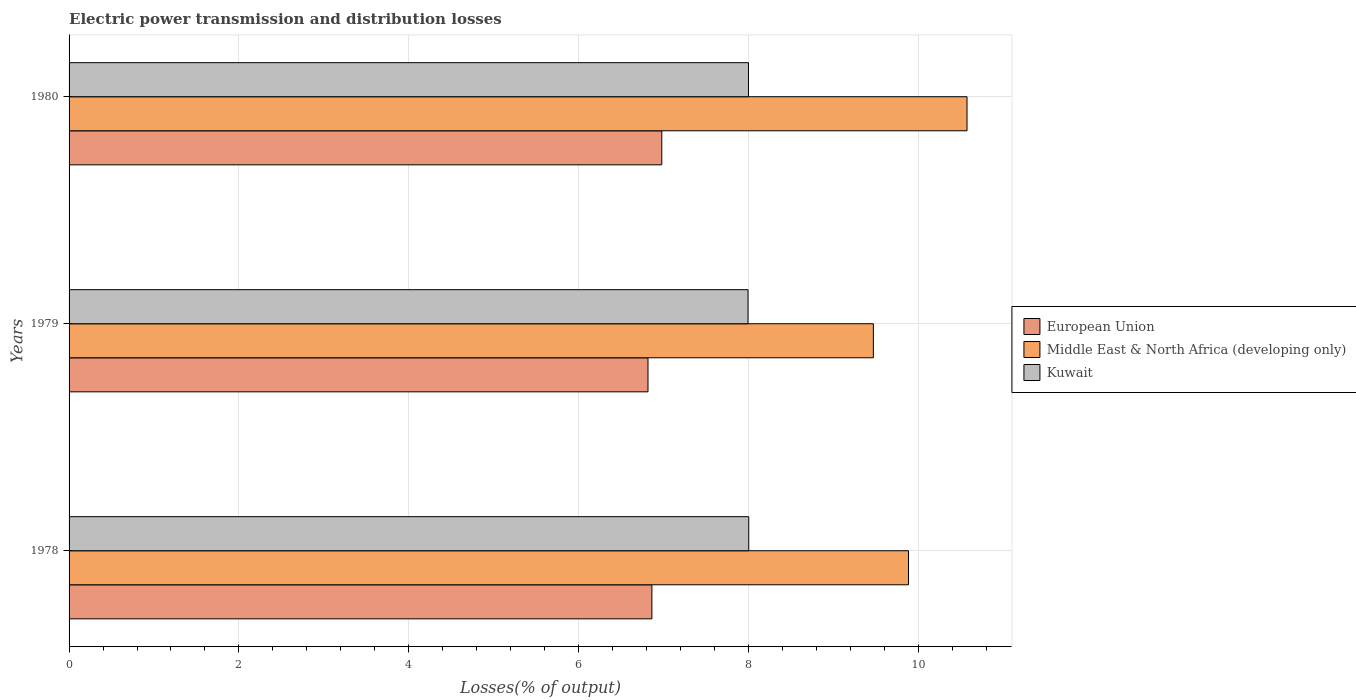How many different coloured bars are there?
Make the answer very short. 3. How many groups of bars are there?
Make the answer very short. 3. How many bars are there on the 2nd tick from the top?
Provide a short and direct response. 3. How many bars are there on the 2nd tick from the bottom?
Keep it short and to the point. 3. What is the label of the 1st group of bars from the top?
Your response must be concise. 1980. What is the electric power transmission and distribution losses in Middle East & North Africa (developing only) in 1980?
Provide a succinct answer. 10.58. Across all years, what is the maximum electric power transmission and distribution losses in Kuwait?
Your answer should be compact. 8.01. Across all years, what is the minimum electric power transmission and distribution losses in Middle East & North Africa (developing only)?
Your response must be concise. 9.47. In which year was the electric power transmission and distribution losses in Kuwait minimum?
Keep it short and to the point. 1979. What is the total electric power transmission and distribution losses in Kuwait in the graph?
Make the answer very short. 24. What is the difference between the electric power transmission and distribution losses in Kuwait in 1978 and that in 1979?
Your answer should be compact. 0.01. What is the difference between the electric power transmission and distribution losses in Middle East & North Africa (developing only) in 1979 and the electric power transmission and distribution losses in Kuwait in 1978?
Offer a terse response. 1.47. What is the average electric power transmission and distribution losses in European Union per year?
Offer a terse response. 6.89. In the year 1978, what is the difference between the electric power transmission and distribution losses in Middle East & North Africa (developing only) and electric power transmission and distribution losses in Kuwait?
Your response must be concise. 1.88. What is the ratio of the electric power transmission and distribution losses in European Union in 1979 to that in 1980?
Offer a terse response. 0.98. Is the electric power transmission and distribution losses in European Union in 1978 less than that in 1980?
Provide a succinct answer. Yes. Is the difference between the electric power transmission and distribution losses in Middle East & North Africa (developing only) in 1979 and 1980 greater than the difference between the electric power transmission and distribution losses in Kuwait in 1979 and 1980?
Provide a succinct answer. No. What is the difference between the highest and the second highest electric power transmission and distribution losses in Middle East & North Africa (developing only)?
Ensure brevity in your answer.  0.69. What is the difference between the highest and the lowest electric power transmission and distribution losses in Middle East & North Africa (developing only)?
Your answer should be very brief. 1.1. What does the 1st bar from the top in 1979 represents?
Your answer should be compact. Kuwait. What does the 2nd bar from the bottom in 1979 represents?
Your response must be concise. Middle East & North Africa (developing only). Is it the case that in every year, the sum of the electric power transmission and distribution losses in Middle East & North Africa (developing only) and electric power transmission and distribution losses in European Union is greater than the electric power transmission and distribution losses in Kuwait?
Provide a short and direct response. Yes. Does the graph contain grids?
Your response must be concise. Yes. Where does the legend appear in the graph?
Ensure brevity in your answer.  Center right. What is the title of the graph?
Ensure brevity in your answer.  Electric power transmission and distribution losses. What is the label or title of the X-axis?
Your response must be concise. Losses(% of output). What is the label or title of the Y-axis?
Provide a short and direct response. Years. What is the Losses(% of output) of European Union in 1978?
Provide a short and direct response. 6.86. What is the Losses(% of output) in Middle East & North Africa (developing only) in 1978?
Your answer should be compact. 9.89. What is the Losses(% of output) of Kuwait in 1978?
Keep it short and to the point. 8.01. What is the Losses(% of output) of European Union in 1979?
Offer a terse response. 6.82. What is the Losses(% of output) of Middle East & North Africa (developing only) in 1979?
Make the answer very short. 9.47. What is the Losses(% of output) of Kuwait in 1979?
Make the answer very short. 8. What is the Losses(% of output) in European Union in 1980?
Your response must be concise. 6.98. What is the Losses(% of output) in Middle East & North Africa (developing only) in 1980?
Give a very brief answer. 10.58. What is the Losses(% of output) in Kuwait in 1980?
Your answer should be very brief. 8. Across all years, what is the maximum Losses(% of output) in European Union?
Keep it short and to the point. 6.98. Across all years, what is the maximum Losses(% of output) of Middle East & North Africa (developing only)?
Your response must be concise. 10.58. Across all years, what is the maximum Losses(% of output) in Kuwait?
Ensure brevity in your answer.  8.01. Across all years, what is the minimum Losses(% of output) of European Union?
Your response must be concise. 6.82. Across all years, what is the minimum Losses(% of output) in Middle East & North Africa (developing only)?
Your answer should be compact. 9.47. Across all years, what is the minimum Losses(% of output) in Kuwait?
Your response must be concise. 8. What is the total Losses(% of output) in European Union in the graph?
Keep it short and to the point. 20.66. What is the total Losses(% of output) in Middle East & North Africa (developing only) in the graph?
Provide a short and direct response. 29.94. What is the total Losses(% of output) in Kuwait in the graph?
Keep it short and to the point. 24. What is the difference between the Losses(% of output) in European Union in 1978 and that in 1979?
Keep it short and to the point. 0.05. What is the difference between the Losses(% of output) of Middle East & North Africa (developing only) in 1978 and that in 1979?
Your answer should be very brief. 0.41. What is the difference between the Losses(% of output) in Kuwait in 1978 and that in 1979?
Offer a very short reply. 0.01. What is the difference between the Losses(% of output) of European Union in 1978 and that in 1980?
Ensure brevity in your answer.  -0.12. What is the difference between the Losses(% of output) in Middle East & North Africa (developing only) in 1978 and that in 1980?
Keep it short and to the point. -0.69. What is the difference between the Losses(% of output) in Kuwait in 1978 and that in 1980?
Offer a very short reply. 0. What is the difference between the Losses(% of output) in European Union in 1979 and that in 1980?
Your answer should be very brief. -0.16. What is the difference between the Losses(% of output) in Middle East & North Africa (developing only) in 1979 and that in 1980?
Provide a succinct answer. -1.1. What is the difference between the Losses(% of output) of Kuwait in 1979 and that in 1980?
Provide a short and direct response. -0.01. What is the difference between the Losses(% of output) in European Union in 1978 and the Losses(% of output) in Middle East & North Africa (developing only) in 1979?
Offer a very short reply. -2.61. What is the difference between the Losses(% of output) of European Union in 1978 and the Losses(% of output) of Kuwait in 1979?
Offer a very short reply. -1.13. What is the difference between the Losses(% of output) in Middle East & North Africa (developing only) in 1978 and the Losses(% of output) in Kuwait in 1979?
Give a very brief answer. 1.89. What is the difference between the Losses(% of output) in European Union in 1978 and the Losses(% of output) in Middle East & North Africa (developing only) in 1980?
Make the answer very short. -3.71. What is the difference between the Losses(% of output) of European Union in 1978 and the Losses(% of output) of Kuwait in 1980?
Provide a short and direct response. -1.14. What is the difference between the Losses(% of output) of Middle East & North Africa (developing only) in 1978 and the Losses(% of output) of Kuwait in 1980?
Provide a succinct answer. 1.88. What is the difference between the Losses(% of output) of European Union in 1979 and the Losses(% of output) of Middle East & North Africa (developing only) in 1980?
Offer a terse response. -3.76. What is the difference between the Losses(% of output) in European Union in 1979 and the Losses(% of output) in Kuwait in 1980?
Offer a very short reply. -1.18. What is the difference between the Losses(% of output) in Middle East & North Africa (developing only) in 1979 and the Losses(% of output) in Kuwait in 1980?
Ensure brevity in your answer.  1.47. What is the average Losses(% of output) in European Union per year?
Your answer should be compact. 6.89. What is the average Losses(% of output) of Middle East & North Africa (developing only) per year?
Keep it short and to the point. 9.98. What is the average Losses(% of output) in Kuwait per year?
Give a very brief answer. 8. In the year 1978, what is the difference between the Losses(% of output) of European Union and Losses(% of output) of Middle East & North Africa (developing only)?
Provide a short and direct response. -3.02. In the year 1978, what is the difference between the Losses(% of output) in European Union and Losses(% of output) in Kuwait?
Your answer should be compact. -1.14. In the year 1978, what is the difference between the Losses(% of output) of Middle East & North Africa (developing only) and Losses(% of output) of Kuwait?
Offer a very short reply. 1.88. In the year 1979, what is the difference between the Losses(% of output) of European Union and Losses(% of output) of Middle East & North Africa (developing only)?
Your response must be concise. -2.65. In the year 1979, what is the difference between the Losses(% of output) of European Union and Losses(% of output) of Kuwait?
Your response must be concise. -1.18. In the year 1979, what is the difference between the Losses(% of output) in Middle East & North Africa (developing only) and Losses(% of output) in Kuwait?
Your answer should be very brief. 1.48. In the year 1980, what is the difference between the Losses(% of output) in European Union and Losses(% of output) in Middle East & North Africa (developing only)?
Make the answer very short. -3.6. In the year 1980, what is the difference between the Losses(% of output) of European Union and Losses(% of output) of Kuwait?
Keep it short and to the point. -1.02. In the year 1980, what is the difference between the Losses(% of output) in Middle East & North Africa (developing only) and Losses(% of output) in Kuwait?
Your response must be concise. 2.57. What is the ratio of the Losses(% of output) in European Union in 1978 to that in 1979?
Give a very brief answer. 1.01. What is the ratio of the Losses(% of output) of Middle East & North Africa (developing only) in 1978 to that in 1979?
Provide a succinct answer. 1.04. What is the ratio of the Losses(% of output) in European Union in 1978 to that in 1980?
Offer a terse response. 0.98. What is the ratio of the Losses(% of output) in Middle East & North Africa (developing only) in 1978 to that in 1980?
Offer a terse response. 0.93. What is the ratio of the Losses(% of output) in European Union in 1979 to that in 1980?
Ensure brevity in your answer.  0.98. What is the ratio of the Losses(% of output) of Middle East & North Africa (developing only) in 1979 to that in 1980?
Give a very brief answer. 0.9. What is the difference between the highest and the second highest Losses(% of output) of European Union?
Your response must be concise. 0.12. What is the difference between the highest and the second highest Losses(% of output) of Middle East & North Africa (developing only)?
Your answer should be compact. 0.69. What is the difference between the highest and the second highest Losses(% of output) of Kuwait?
Your response must be concise. 0. What is the difference between the highest and the lowest Losses(% of output) in European Union?
Make the answer very short. 0.16. What is the difference between the highest and the lowest Losses(% of output) in Middle East & North Africa (developing only)?
Your response must be concise. 1.1. What is the difference between the highest and the lowest Losses(% of output) in Kuwait?
Provide a succinct answer. 0.01. 